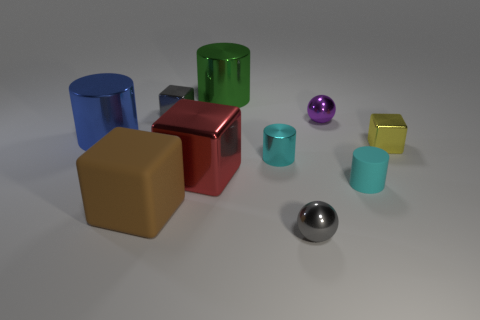Subtract all yellow spheres. How many cyan cylinders are left? 2 Subtract all tiny rubber cylinders. How many cylinders are left? 3 Subtract all gray cubes. How many cubes are left? 3 Subtract all blue cubes. Subtract all blue balls. How many cubes are left? 4 Subtract all blocks. How many objects are left? 6 Subtract all tiny cyan metal blocks. Subtract all big red shiny cubes. How many objects are left? 9 Add 9 tiny purple shiny balls. How many tiny purple shiny balls are left? 10 Add 9 large yellow cylinders. How many large yellow cylinders exist? 9 Subtract 0 gray cylinders. How many objects are left? 10 